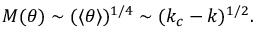<formula> <loc_0><loc_0><loc_500><loc_500>M ( \theta ) \sim ( \langle \theta \rangle ) ^ { 1 / 4 } \sim ( k _ { c } - k ) ^ { 1 / 2 } .</formula> 